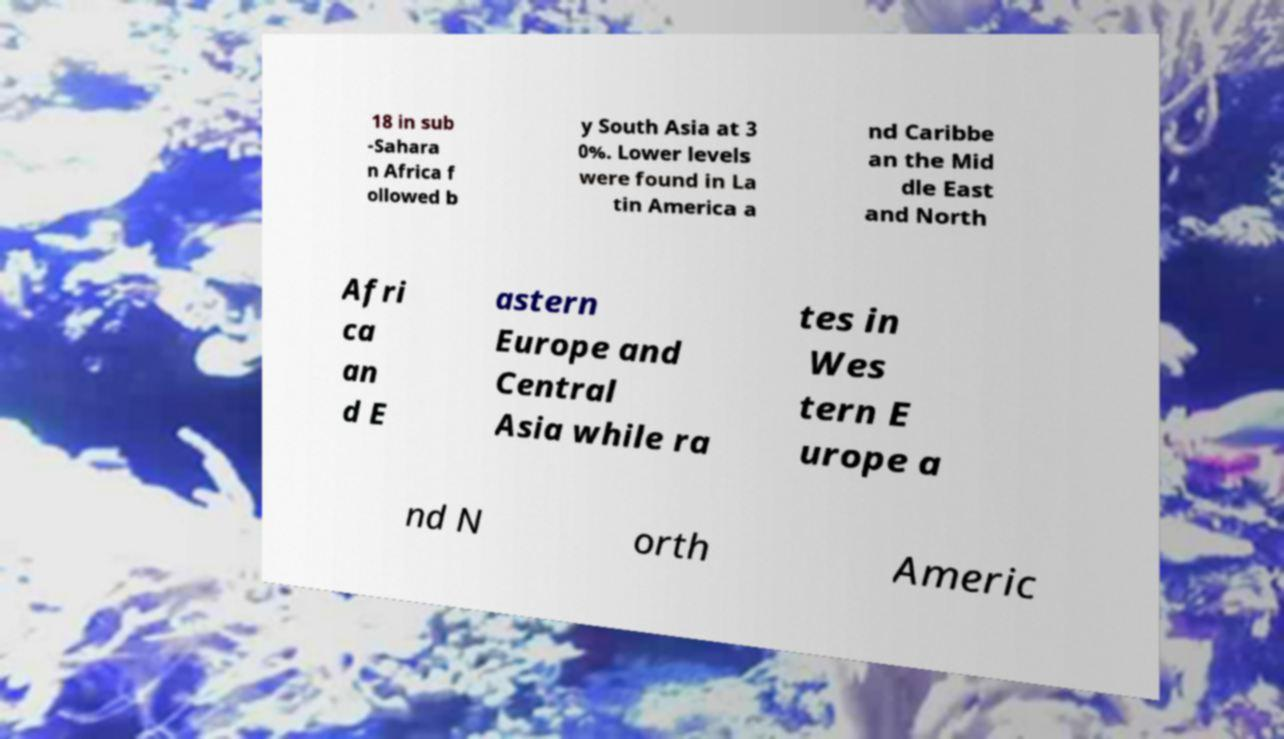There's text embedded in this image that I need extracted. Can you transcribe it verbatim? 18 in sub -Sahara n Africa f ollowed b y South Asia at 3 0%. Lower levels were found in La tin America a nd Caribbe an the Mid dle East and North Afri ca an d E astern Europe and Central Asia while ra tes in Wes tern E urope a nd N orth Americ 